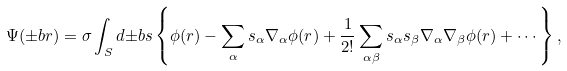<formula> <loc_0><loc_0><loc_500><loc_500>\Psi ( { \pm b r } ) = \sigma \int _ { S } d { \pm b s } \left \{ \phi ( r ) - \sum _ { \alpha } s _ { \alpha } \nabla _ { \alpha } \phi ( r ) + \frac { 1 } { 2 ! } \sum _ { \alpha \beta } s _ { \alpha } s _ { \beta } \nabla _ { \alpha } \nabla _ { \beta } \phi ( r ) + \cdots \right \} ,</formula> 